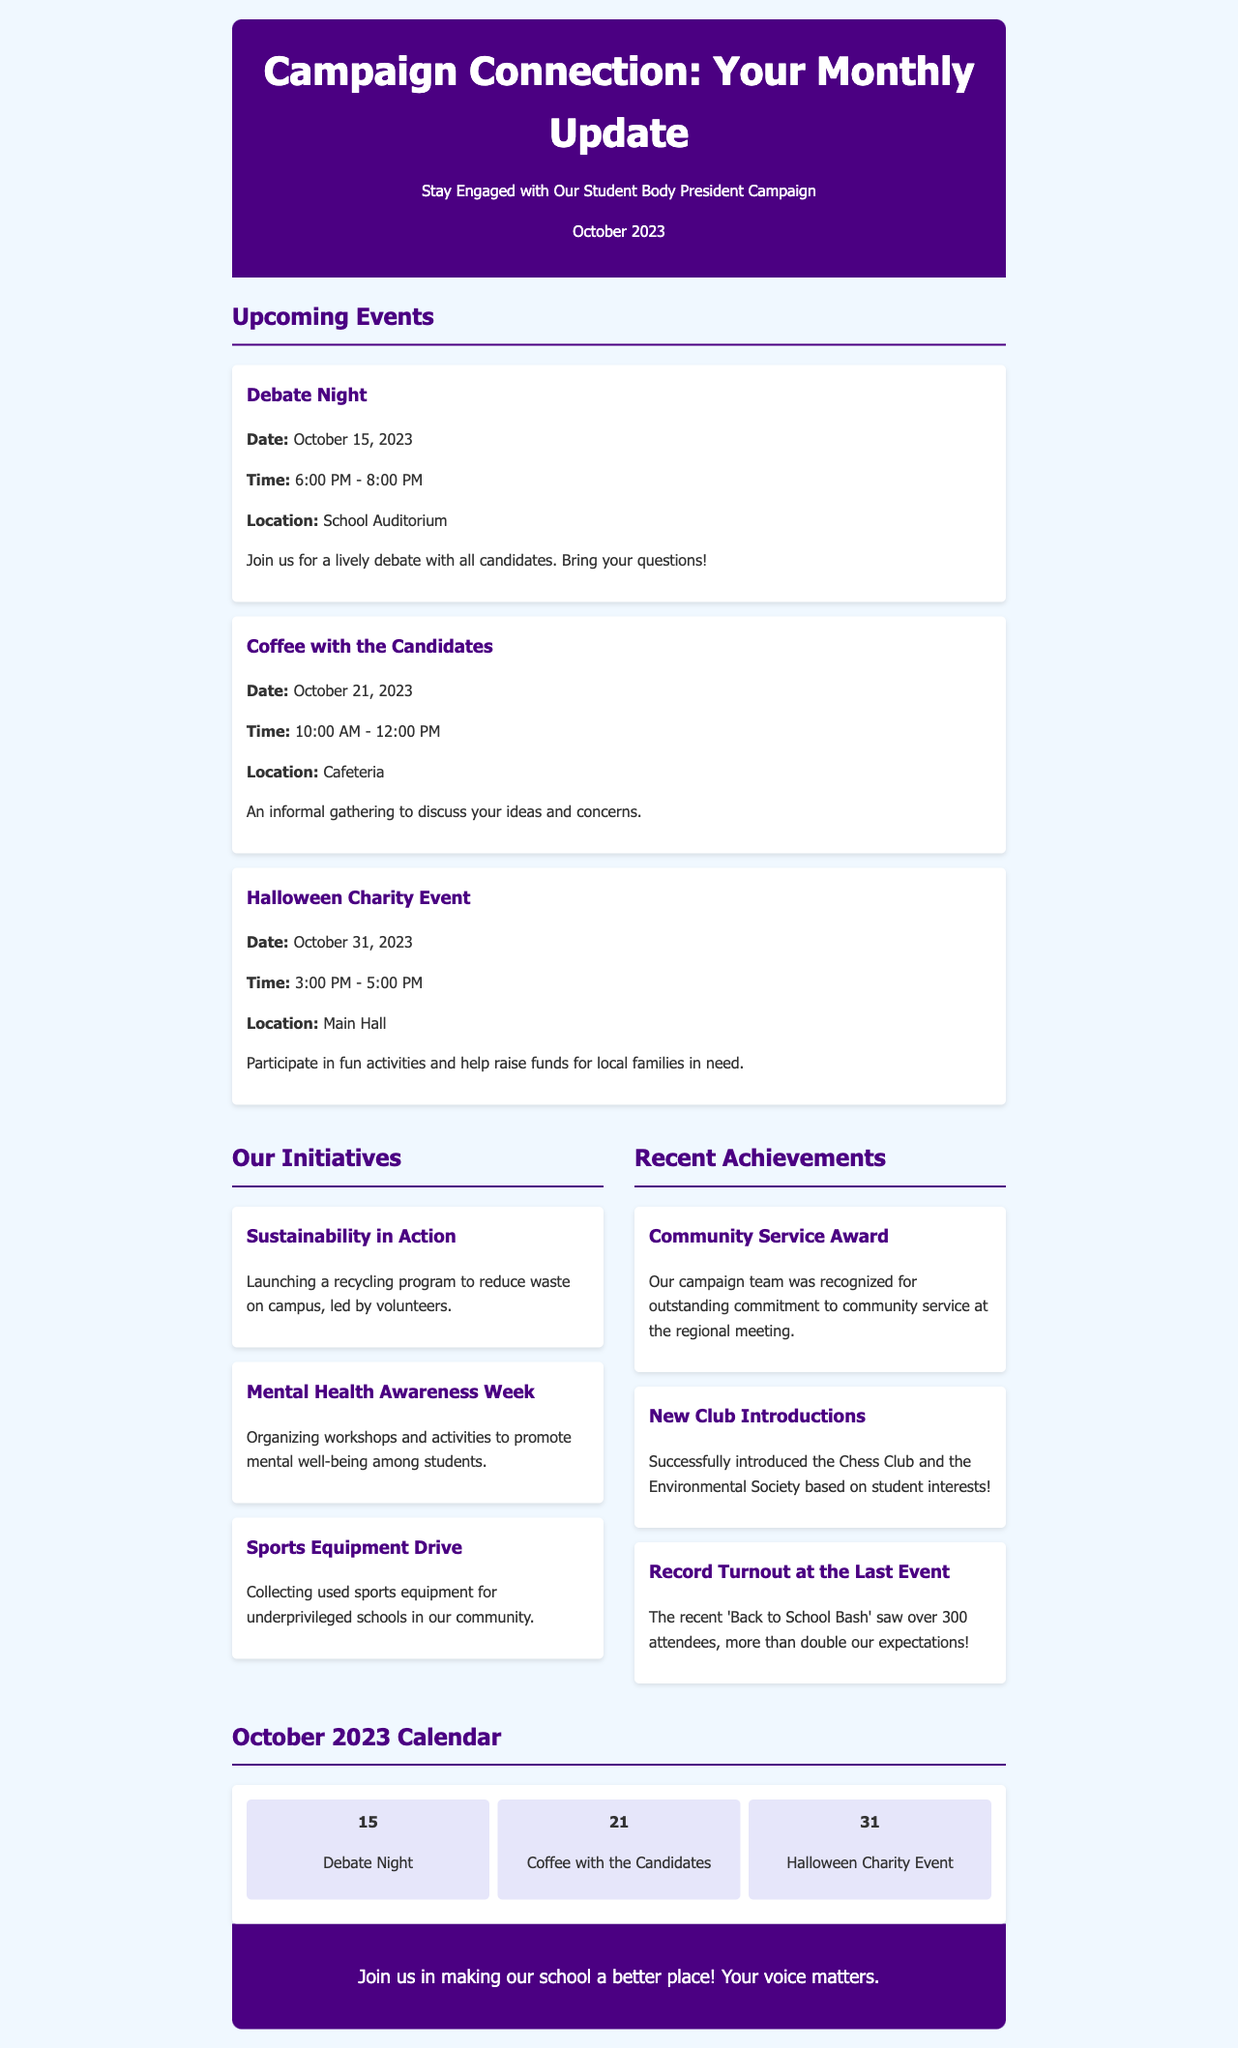What is the title of the newsletter? The title of the newsletter is located in the header section of the document.
Answer: Campaign Connection: Your Monthly Update What is the date of the Debate Night event? This information is provided within the Upcoming Events section.
Answer: October 15, 2023 How long will the Coffee with the Candidates event last? The duration of the event can be found in the event details.
Answer: 2 hours Which initiative focuses on environmental efforts? This information can be found in the Our Initiatives section where different initiatives are listed.
Answer: Sustainability in Action What was the recent achievement related to club introductions? The Recent Achievements section provides details about new club introductions.
Answer: Successfully introduced the Chess Club and the Environmental Society What time does the Halloween Charity Event start? This specific detail is included in the event description of the Halloween Charity Event.
Answer: 3:00 PM How many attendees were at the 'Back to School Bash'? The achievement gives a quantifiable measure of the event turnout.
Answer: Over 300 attendees What is the location of the Debate Night event? The location is explicitly mentioned in the event description.
Answer: School Auditorium What color is used for the header background? This detail refers to the visual aspect of the document, specifically the header's background color.
Answer: #4b0082 